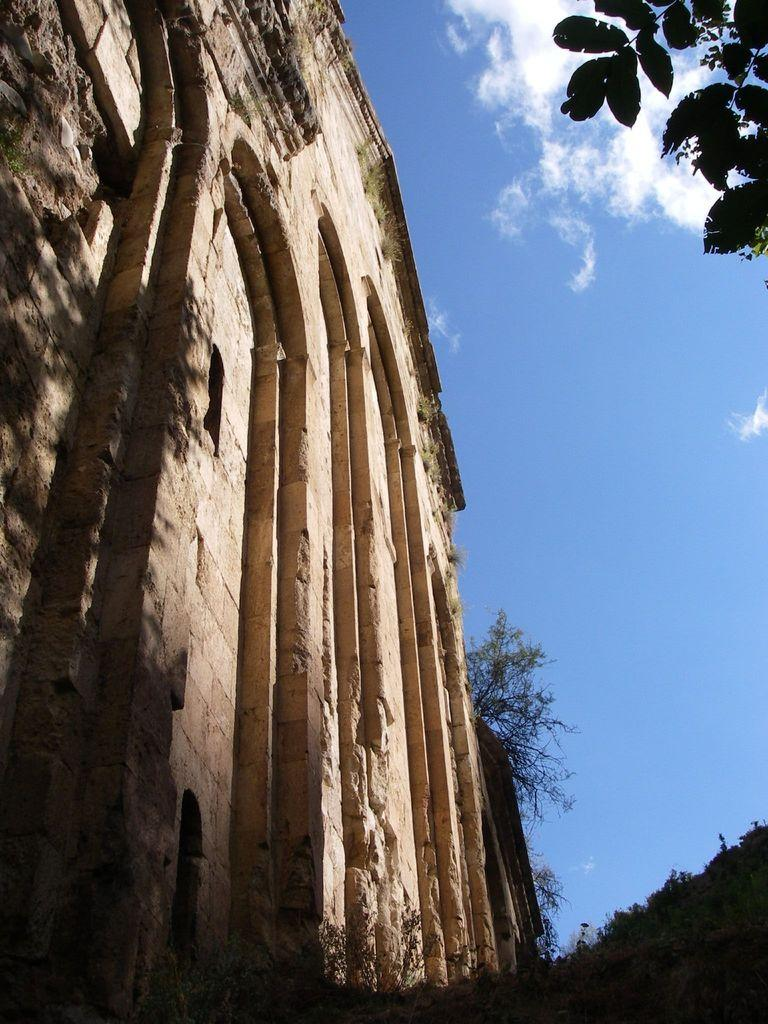What type of structure is visible in the image? There is a building in the image. What other natural elements can be seen in the image? There are trees in the image. What is visible in the background of the image? The sky is visible in the background of the image. What can be observed in the sky? Clouds are present in the sky. What type of chain can be seen hanging from the building in the image? There is no chain visible hanging from the building in the image. 